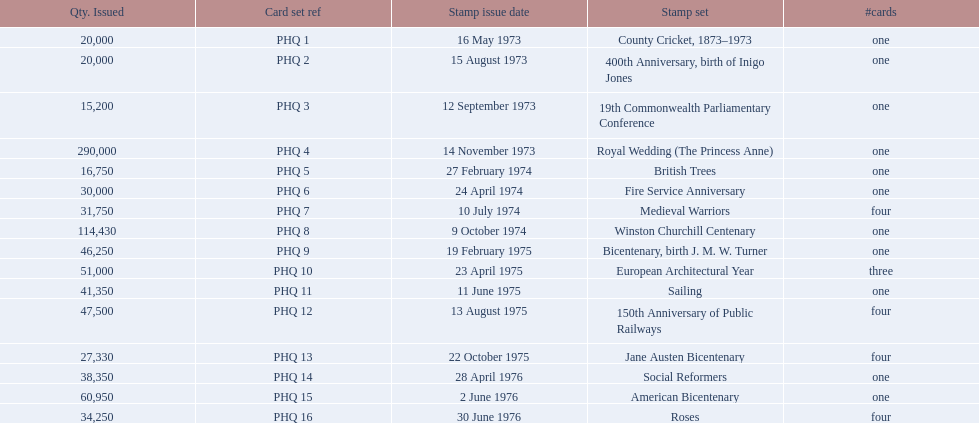Which stamp sets contained more than one card? Medieval Warriors, European Architectural Year, 150th Anniversary of Public Railways, Jane Austen Bicentenary, Roses. Of those stamp sets, which contains a unique number of cards? European Architectural Year. Give me the full table as a dictionary. {'header': ['Qty. Issued', 'Card set ref', 'Stamp issue date', 'Stamp set', '#cards'], 'rows': [['20,000', 'PHQ 1', '16 May 1973', 'County Cricket, 1873–1973', 'one'], ['20,000', 'PHQ 2', '15 August 1973', '400th Anniversary, birth of Inigo Jones', 'one'], ['15,200', 'PHQ 3', '12 September 1973', '19th Commonwealth Parliamentary Conference', 'one'], ['290,000', 'PHQ 4', '14 November 1973', 'Royal Wedding (The Princess Anne)', 'one'], ['16,750', 'PHQ 5', '27 February 1974', 'British Trees', 'one'], ['30,000', 'PHQ 6', '24 April 1974', 'Fire Service Anniversary', 'one'], ['31,750', 'PHQ 7', '10 July 1974', 'Medieval Warriors', 'four'], ['114,430', 'PHQ 8', '9 October 1974', 'Winston Churchill Centenary', 'one'], ['46,250', 'PHQ 9', '19 February 1975', 'Bicentenary, birth J. M. W. Turner', 'one'], ['51,000', 'PHQ 10', '23 April 1975', 'European Architectural Year', 'three'], ['41,350', 'PHQ 11', '11 June 1975', 'Sailing', 'one'], ['47,500', 'PHQ 12', '13 August 1975', '150th Anniversary of Public Railways', 'four'], ['27,330', 'PHQ 13', '22 October 1975', 'Jane Austen Bicentenary', 'four'], ['38,350', 'PHQ 14', '28 April 1976', 'Social Reformers', 'one'], ['60,950', 'PHQ 15', '2 June 1976', 'American Bicentenary', 'one'], ['34,250', 'PHQ 16', '30 June 1976', 'Roses', 'four']]} 